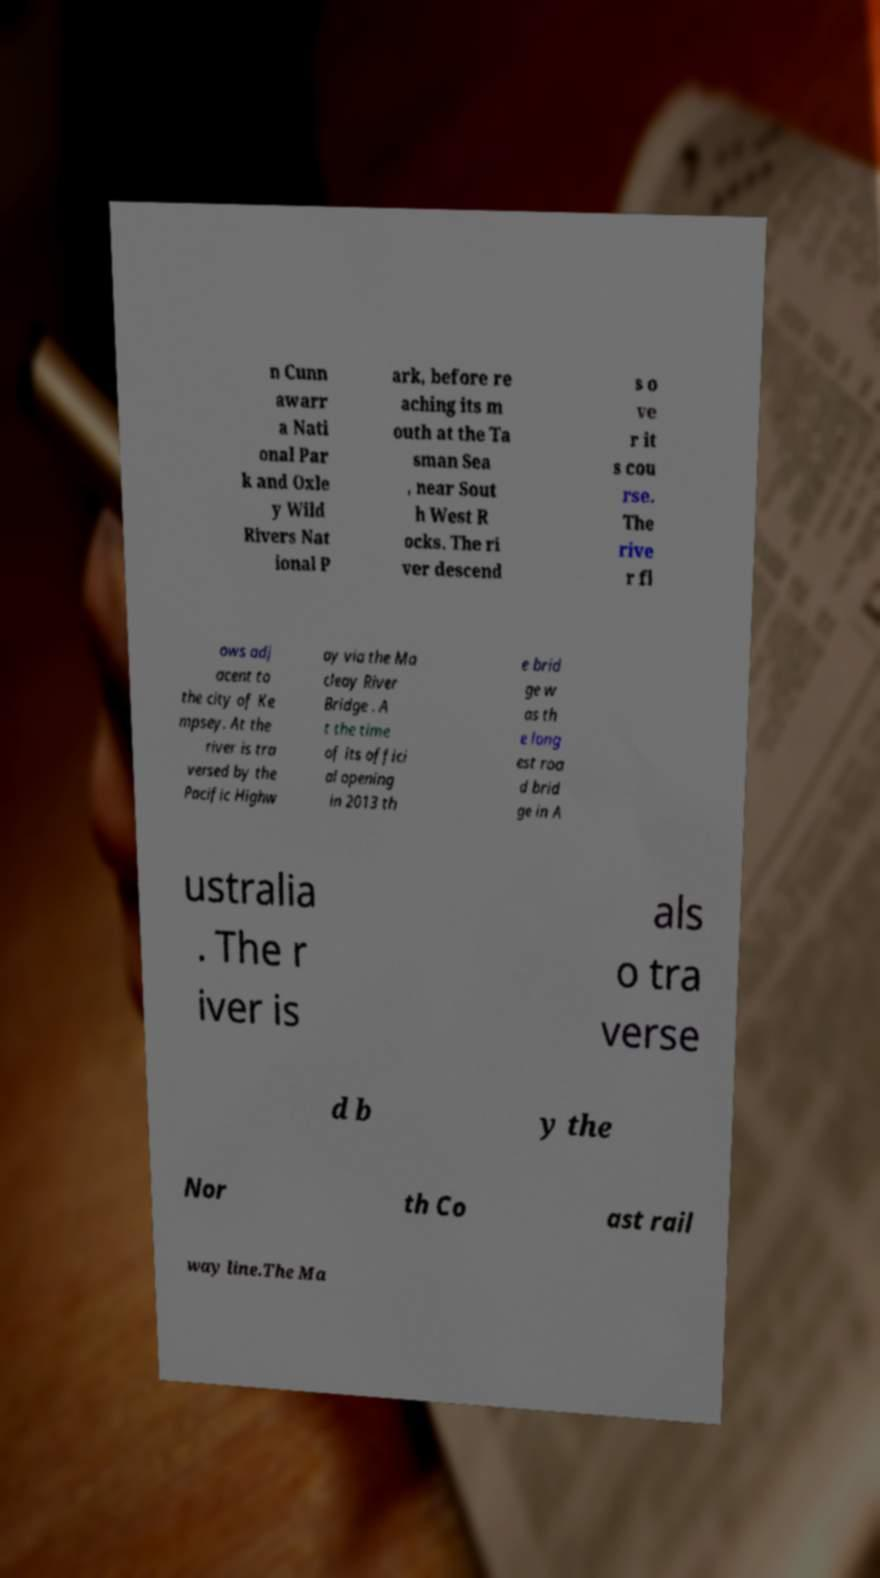Please identify and transcribe the text found in this image. n Cunn awarr a Nati onal Par k and Oxle y Wild Rivers Nat ional P ark, before re aching its m outh at the Ta sman Sea , near Sout h West R ocks. The ri ver descend s o ve r it s cou rse. The rive r fl ows adj acent to the city of Ke mpsey. At the river is tra versed by the Pacific Highw ay via the Ma cleay River Bridge . A t the time of its offici al opening in 2013 th e brid ge w as th e long est roa d brid ge in A ustralia . The r iver is als o tra verse d b y the Nor th Co ast rail way line.The Ma 